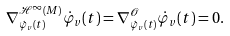Convert formula to latex. <formula><loc_0><loc_0><loc_500><loc_500>\nabla _ { \dot { \varphi } _ { v } ( t ) } ^ { \mathcal { H } ^ { \infty } ( M ) } \dot { \varphi } _ { v } ( t ) = \nabla _ { \dot { \varphi } _ { v } ( t ) } ^ { \mathcal { O } } \dot { \varphi } _ { v } ( t ) = 0 .</formula> 